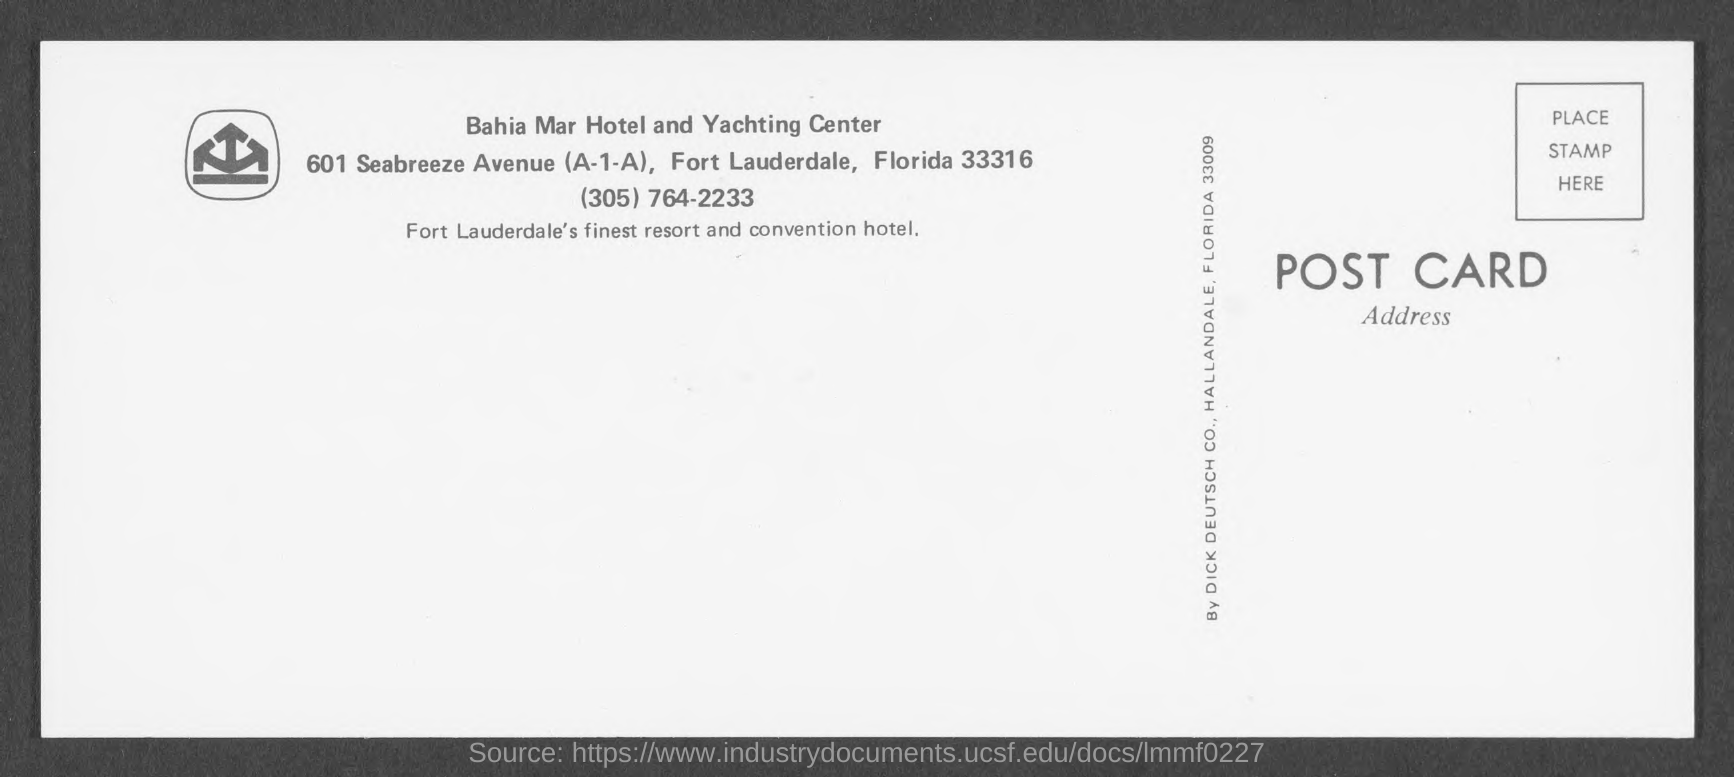What is the zip code of fort lauderdale?
Ensure brevity in your answer.  33316. 